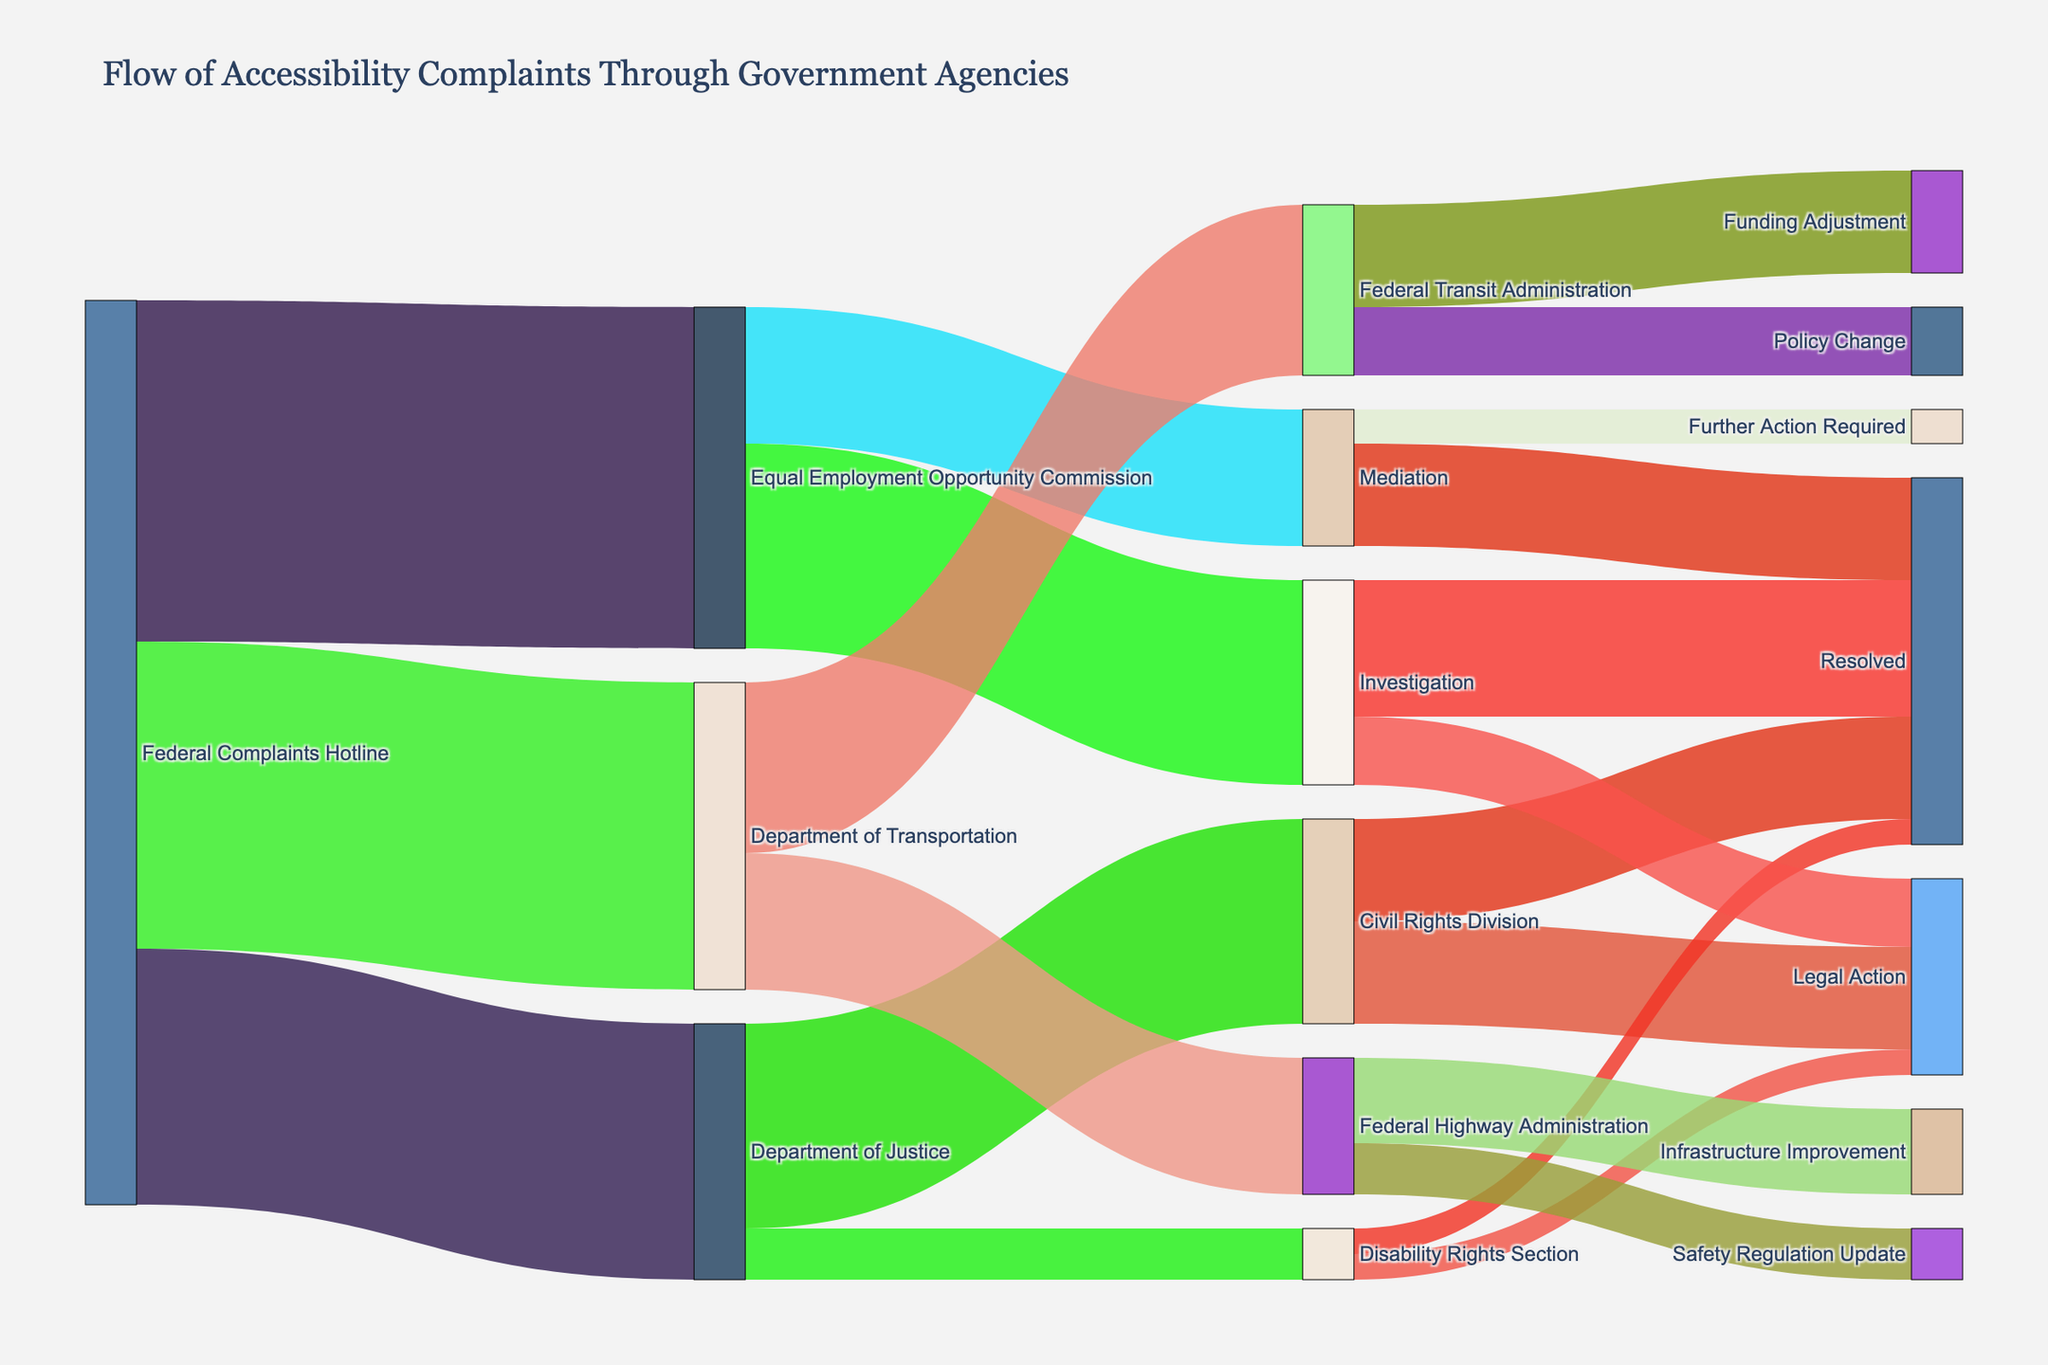What is the title of the figure? The title is usually displayed at the top of the figure. In this case, the title provides an overview of what the diagram represents.
Answer: "Flow of Accessibility Complaints Through Government Agencies" Which entity received the highest number of complaints from the Federal Complaints Hotline? The diagram shows the value of complaints flowing from the Federal Complaints Hotline to various agencies. By looking for the highest value, we can identify the entity.
Answer: Equal Employment Opportunity Commission How many complaints were handled by the Civil Rights Division, regardless of outcome? To find this, sum the values of all paths leading to the Civil Rights Division.
Answer: 1200 Which agency is responsible for the highest number of resolved complaints? Examine the paths leading to 'Resolved' for each agency and compare their values.
Answer: Investigation How many complaints were reported to the Department of Justice? Combine the number of complaints going to the Civil Rights Division and Disability Rights Section.
Answer: 1500 Compare the number of complaints leading to Mediation versus Investigation within the Equal Employment Opportunity Commission. Which path has more complaints? Look at the values for connections from the Equal Employment Opportunity Commission to Mediation and Investigation, then compare them.
Answer: Investigation What proportion of complaints from the Equal Employment Opportunity Commission's Investigation process resulted in Legal Action? Calculate the proportion by dividing the value leading to Legal Action by the total complaints in Investigation.
Answer: 1/3 After moving through the Department of Transportation, how many complaints led to Infrastructure Improvement? Sum the values leading to the Federal Highway Administration and Safety Regulation Update and then specify the value for Infrastructure Improvement.
Answer: 500 Which downstream path from the Federal Transit Administration affects the most complaints? Compare the values for paths leading from the Federal Transit Administration and identify the highest value.
Answer: Funding Adjustment What is the total number of complaints resolved across all agencies? Sum the values of all paths leading to 'Resolved' across various agencies.
Answer: 2200 